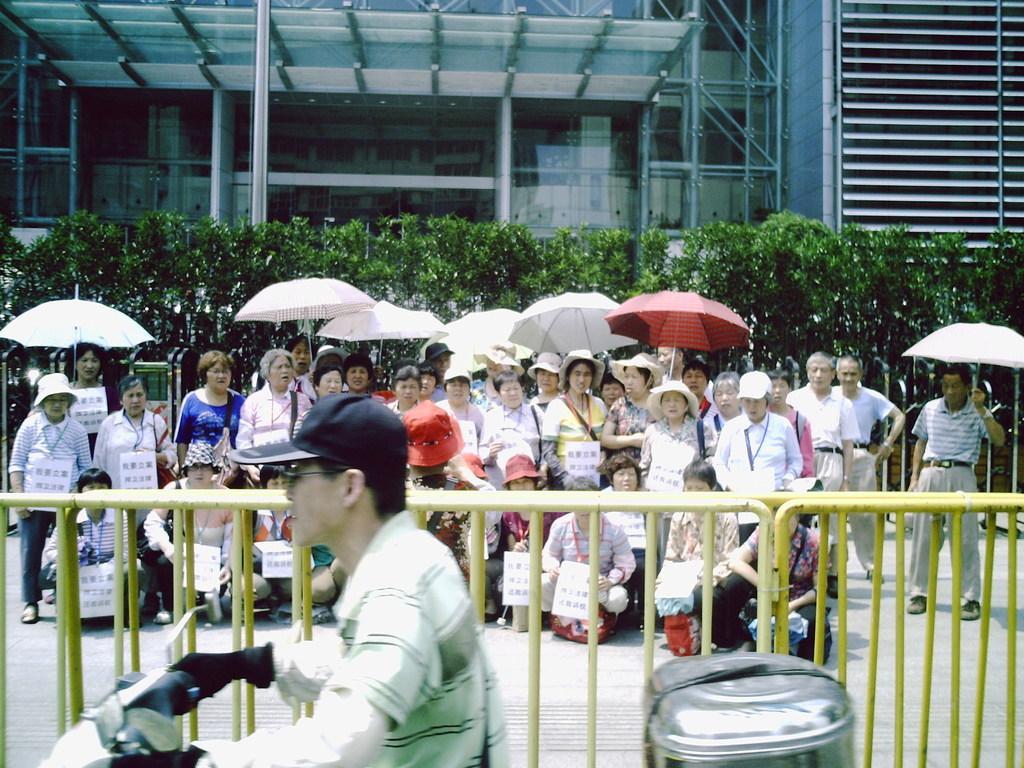Describe this image in one or two sentences. In the picture I can see a person wearing T-shirt, spectacles, cap and gloves is riding the scooter. Here I can see road barriers, many people among them few are standing and few are in the squat position and they are holding the placards in their hands and few are holding umbrellas, I can see the shrubs and the glass building in the background. 